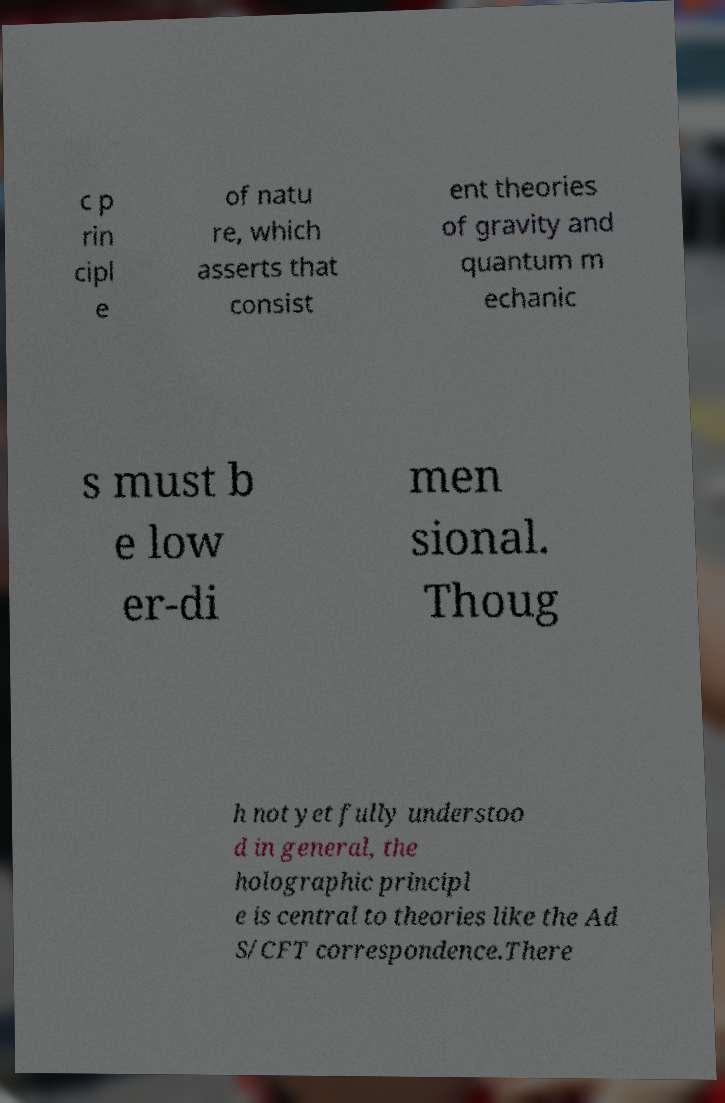For documentation purposes, I need the text within this image transcribed. Could you provide that? c p rin cipl e of natu re, which asserts that consist ent theories of gravity and quantum m echanic s must b e low er-di men sional. Thoug h not yet fully understoo d in general, the holographic principl e is central to theories like the Ad S/CFT correspondence.There 